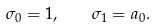<formula> <loc_0><loc_0><loc_500><loc_500>\sigma _ { 0 } = 1 , \quad \sigma _ { 1 } = a _ { 0 } .</formula> 